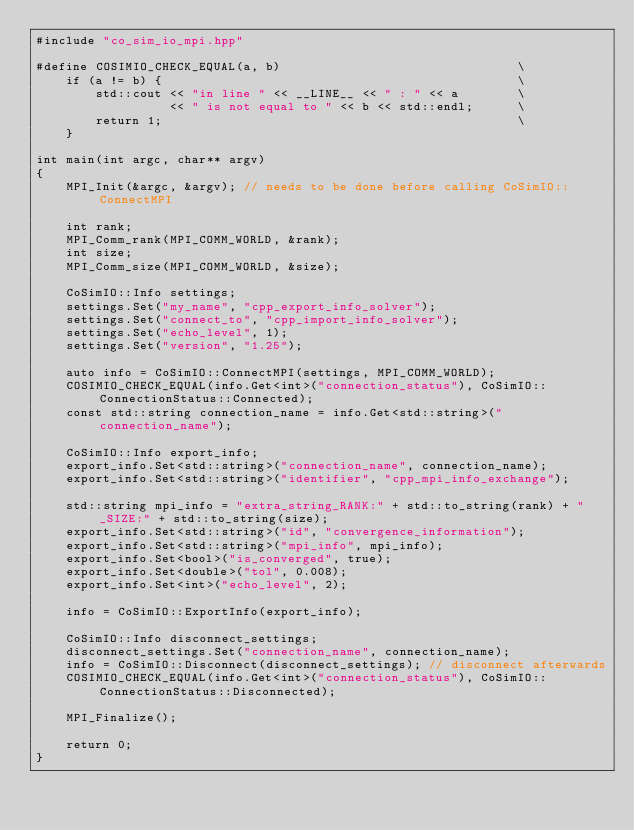<code> <loc_0><loc_0><loc_500><loc_500><_C++_>#include "co_sim_io_mpi.hpp"

#define COSIMIO_CHECK_EQUAL(a, b)                                \
    if (a != b) {                                                \
        std::cout << "in line " << __LINE__ << " : " << a        \
                  << " is not equal to " << b << std::endl;      \
        return 1;                                                \
    }

int main(int argc, char** argv)
{
    MPI_Init(&argc, &argv); // needs to be done before calling CoSimIO::ConnectMPI

    int rank;
    MPI_Comm_rank(MPI_COMM_WORLD, &rank);
    int size;
    MPI_Comm_size(MPI_COMM_WORLD, &size);

    CoSimIO::Info settings;
    settings.Set("my_name", "cpp_export_info_solver");
    settings.Set("connect_to", "cpp_import_info_solver");
    settings.Set("echo_level", 1);
    settings.Set("version", "1.25");

    auto info = CoSimIO::ConnectMPI(settings, MPI_COMM_WORLD);
    COSIMIO_CHECK_EQUAL(info.Get<int>("connection_status"), CoSimIO::ConnectionStatus::Connected);
    const std::string connection_name = info.Get<std::string>("connection_name");

    CoSimIO::Info export_info;
    export_info.Set<std::string>("connection_name", connection_name);
    export_info.Set<std::string>("identifier", "cpp_mpi_info_exchange");

    std::string mpi_info = "extra_string_RANK:" + std::to_string(rank) + "_SIZE:" + std::to_string(size);
    export_info.Set<std::string>("id", "convergence_information");
    export_info.Set<std::string>("mpi_info", mpi_info);
    export_info.Set<bool>("is_converged", true);
    export_info.Set<double>("tol", 0.008);
    export_info.Set<int>("echo_level", 2);

    info = CoSimIO::ExportInfo(export_info);

    CoSimIO::Info disconnect_settings;
    disconnect_settings.Set("connection_name", connection_name);
    info = CoSimIO::Disconnect(disconnect_settings); // disconnect afterwards
    COSIMIO_CHECK_EQUAL(info.Get<int>("connection_status"), CoSimIO::ConnectionStatus::Disconnected);

    MPI_Finalize();

    return 0;
}
</code> 